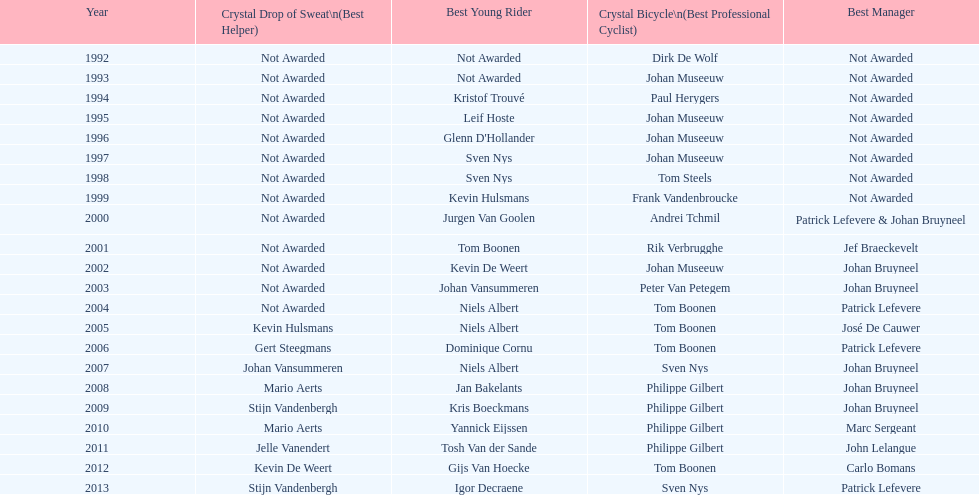What is the average number of times johan museeuw starred? 5. 